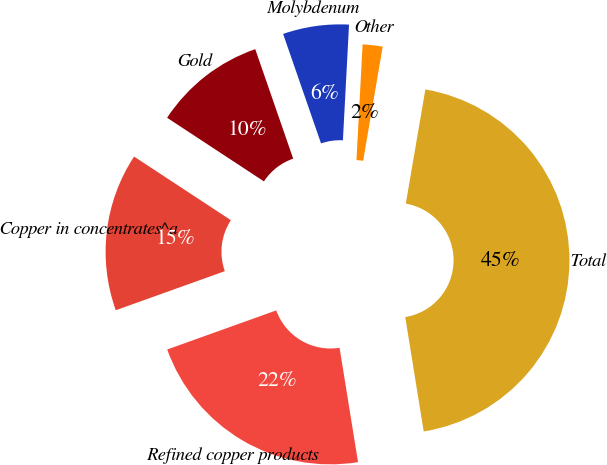<chart> <loc_0><loc_0><loc_500><loc_500><pie_chart><fcel>Refined copper products<fcel>Copper in concentrates^a<fcel>Gold<fcel>Molybdenum<fcel>Other<fcel>Total<nl><fcel>22.07%<fcel>14.73%<fcel>10.44%<fcel>6.15%<fcel>1.86%<fcel>44.75%<nl></chart> 